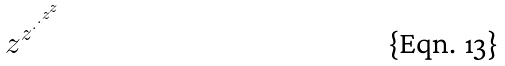Convert formula to latex. <formula><loc_0><loc_0><loc_500><loc_500>z ^ { z ^ { \cdot ^ { \cdot ^ { z ^ { z } } } } }</formula> 